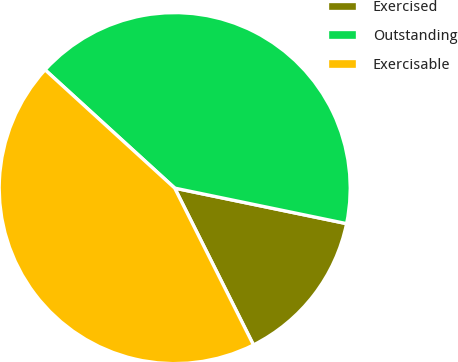<chart> <loc_0><loc_0><loc_500><loc_500><pie_chart><fcel>Exercised<fcel>Outstanding<fcel>Exercisable<nl><fcel>14.35%<fcel>41.47%<fcel>44.18%<nl></chart> 